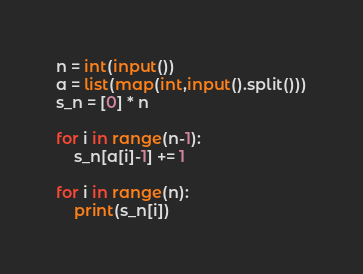<code> <loc_0><loc_0><loc_500><loc_500><_Python_>n = int(input())
a = list(map(int,input().split()))
s_n = [0] * n

for i in range(n-1):
    s_n[a[i]-1] += 1

for i in range(n):
    print(s_n[i])</code> 